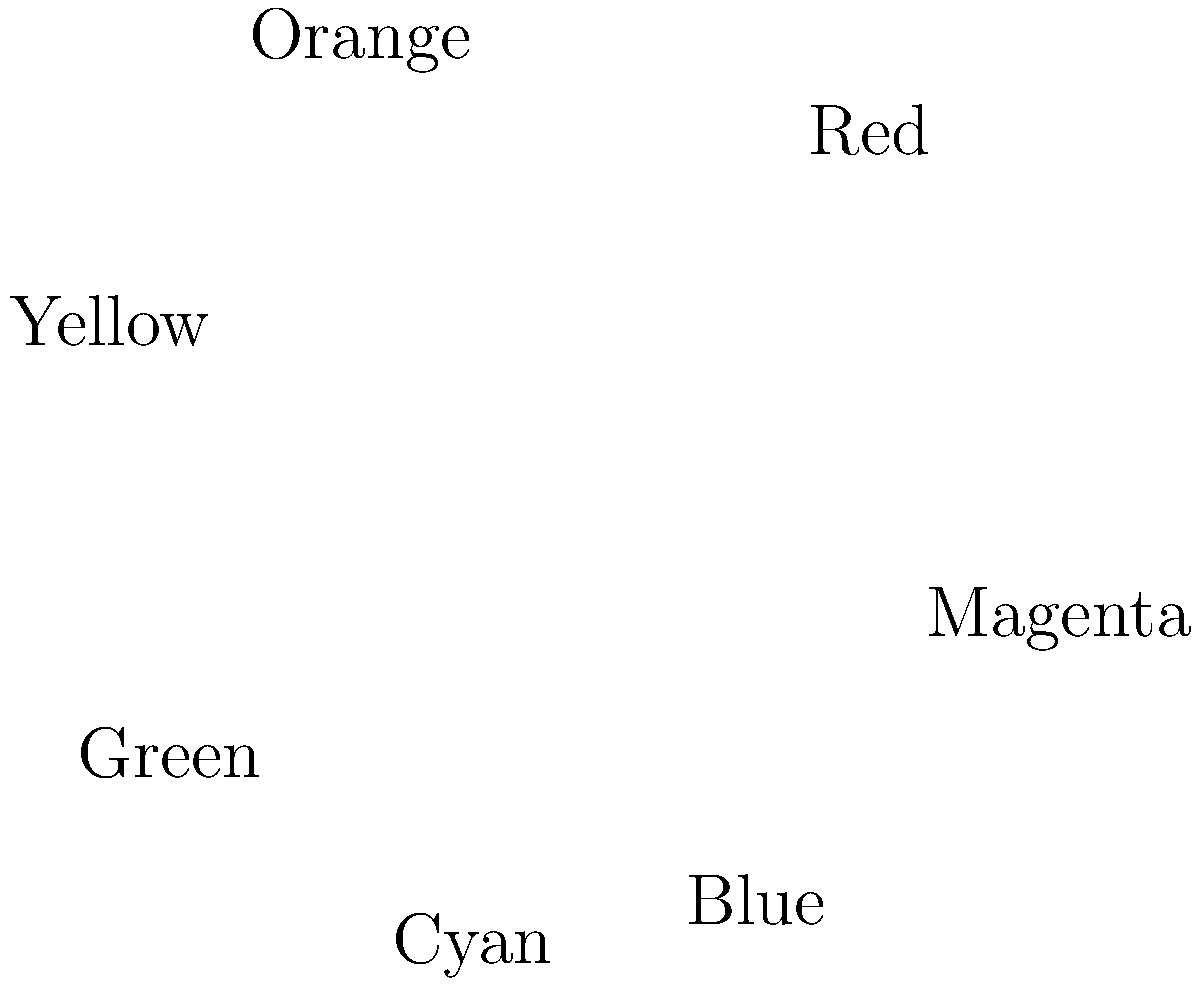Analyze the color palette represented in this pie chart, which depicts the distribution of colors in a mural by Dana Chandler, a prominent African-American artist from Boston. Which color dominates the composition, and how might this reflect Chandler's artistic vision or cultural themes? To answer this question, we need to analyze the color distribution in the pie chart and consider its significance in the context of Dana Chandler's work:

1. Examine the pie chart:
   The chart shows seven colors: Red, Orange, Yellow, Green, Cyan, Blue, and Magenta.

2. Identify the dominant color:
   Red occupies the largest section of the pie chart, representing 25% of the color composition.

3. Consider the significance of red in Chandler's work:
   - Red often symbolizes passion, energy, strength, and revolution in art.
   - In African-American art, red can represent blood, sacrifice, and the struggle for civil rights.
   - Chandler, known for his politically charged works, might use red to evoke strong emotions or make a statement about social issues.

4. Analyze the overall palette:
   - Warm colors (Red, Orange, Yellow) make up 50% of the composition, creating a sense of energy and vibrancy.
   - Cool colors (Green, Cyan, Blue) account for 40%, providing balance and depth.
   - Magenta (10%) adds a touch of complexity and tension to the palette.

5. Interpret the color choices:
   - The dominance of warm colors, especially red, suggests a bold, assertive message.
   - The balance with cool colors might represent hope or progress within the struggle.
   - The diverse palette could symbolize the richness and complexity of African-American experiences in Boston.

6. Connect to Chandler's artistic vision:
   - As a member of the Black Arts Movement, Chandler often addressed social and political issues in his work.
   - The strong use of red aligns with his reputation for creating powerful, thought-provoking art that challenges viewers and promotes social change.
Answer: Red dominates (25%), likely symbolizing passion, struggle, and the African-American experience in Chandler's politically charged art. 